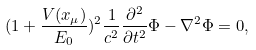Convert formula to latex. <formula><loc_0><loc_0><loc_500><loc_500>( 1 + \frac { V ( x _ { \mu } ) } { E _ { 0 } } ) ^ { 2 } \frac { 1 } { c ^ { 2 } } \frac { \partial ^ { 2 } } { \partial t ^ { 2 } } \Phi - \nabla ^ { 2 } \Phi = 0 ,</formula> 